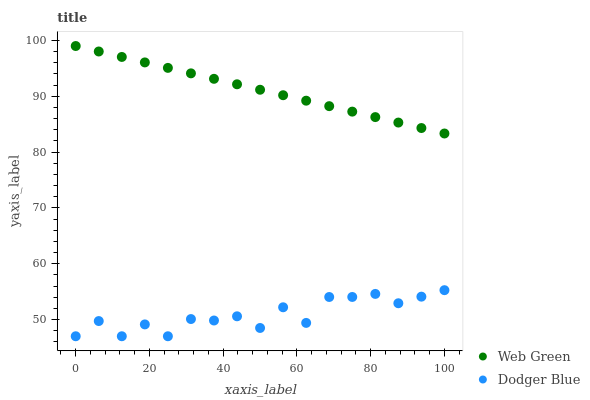Does Dodger Blue have the minimum area under the curve?
Answer yes or no. Yes. Does Web Green have the maximum area under the curve?
Answer yes or no. Yes. Does Web Green have the minimum area under the curve?
Answer yes or no. No. Is Web Green the smoothest?
Answer yes or no. Yes. Is Dodger Blue the roughest?
Answer yes or no. Yes. Is Web Green the roughest?
Answer yes or no. No. Does Dodger Blue have the lowest value?
Answer yes or no. Yes. Does Web Green have the lowest value?
Answer yes or no. No. Does Web Green have the highest value?
Answer yes or no. Yes. Is Dodger Blue less than Web Green?
Answer yes or no. Yes. Is Web Green greater than Dodger Blue?
Answer yes or no. Yes. Does Dodger Blue intersect Web Green?
Answer yes or no. No. 